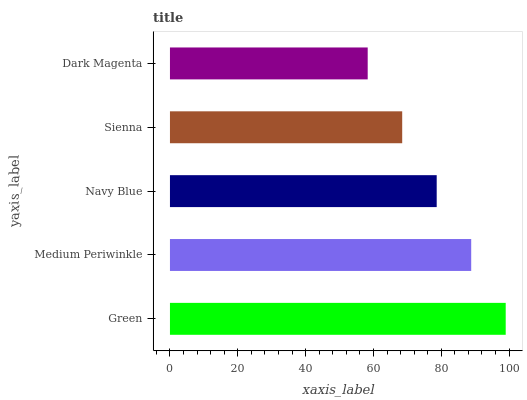Is Dark Magenta the minimum?
Answer yes or no. Yes. Is Green the maximum?
Answer yes or no. Yes. Is Medium Periwinkle the minimum?
Answer yes or no. No. Is Medium Periwinkle the maximum?
Answer yes or no. No. Is Green greater than Medium Periwinkle?
Answer yes or no. Yes. Is Medium Periwinkle less than Green?
Answer yes or no. Yes. Is Medium Periwinkle greater than Green?
Answer yes or no. No. Is Green less than Medium Periwinkle?
Answer yes or no. No. Is Navy Blue the high median?
Answer yes or no. Yes. Is Navy Blue the low median?
Answer yes or no. Yes. Is Green the high median?
Answer yes or no. No. Is Sienna the low median?
Answer yes or no. No. 